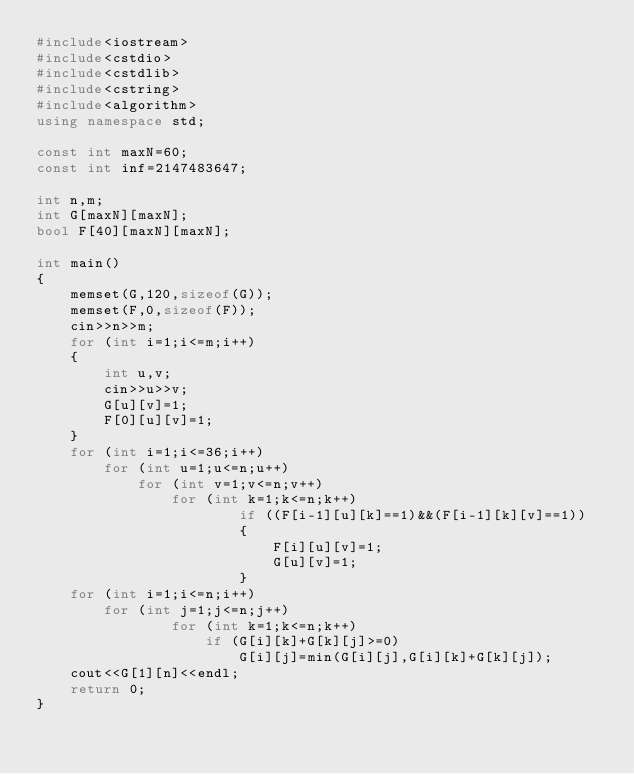Convert code to text. <code><loc_0><loc_0><loc_500><loc_500><_C++_>#include<iostream>
#include<cstdio>
#include<cstdlib>
#include<cstring>
#include<algorithm>
using namespace std;

const int maxN=60;
const int inf=2147483647;

int n,m;
int G[maxN][maxN];
bool F[40][maxN][maxN];

int main()
{
	memset(G,120,sizeof(G));
	memset(F,0,sizeof(F));
	cin>>n>>m;
	for (int i=1;i<=m;i++)
	{
		int u,v;
		cin>>u>>v;
		G[u][v]=1;
		F[0][u][v]=1;
	}
	for (int i=1;i<=36;i++)
	    for (int u=1;u<=n;u++)
			for (int v=1;v<=n;v++)
				for (int k=1;k<=n;k++)
						if ((F[i-1][u][k]==1)&&(F[i-1][k][v]==1))
						{
							F[i][u][v]=1;
							G[u][v]=1;
						}
    for (int i=1;i<=n;i++)
		for (int j=1;j<=n;j++)
				for (int k=1;k<=n;k++)
					if (G[i][k]+G[k][j]>=0)
						G[i][j]=min(G[i][j],G[i][k]+G[k][j]);
	cout<<G[1][n]<<endl;
	return 0;
}
</code> 